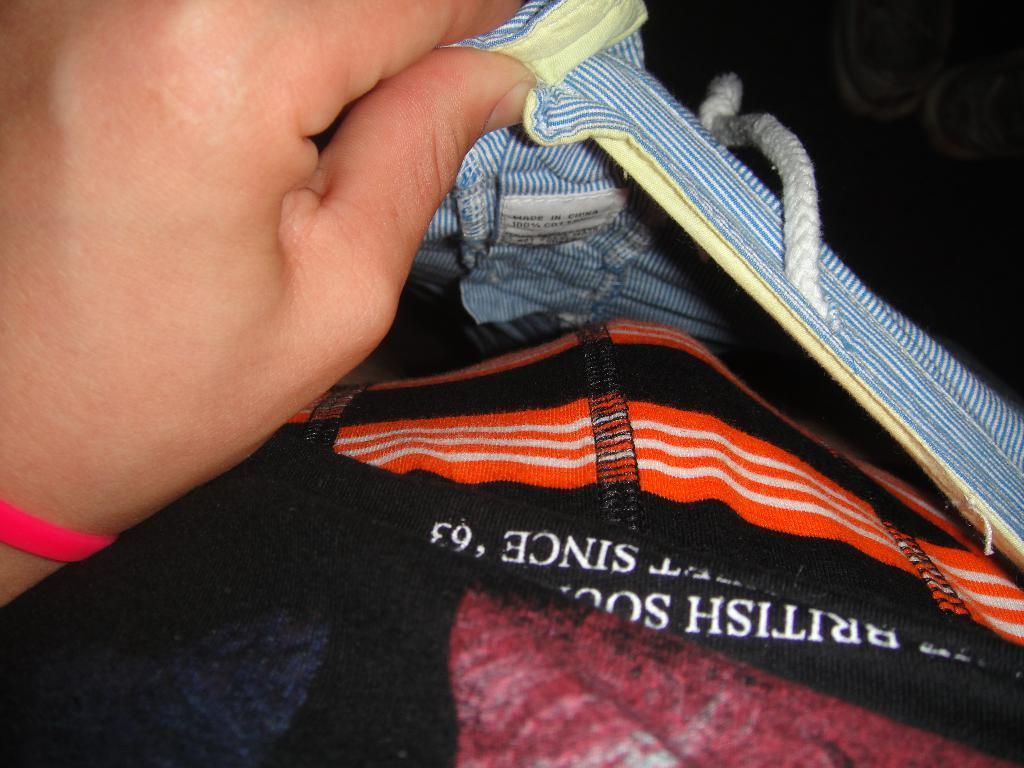Who or what is present in the image? There is a person in the image. What is the person holding? The person is holding clothes. Can you describe any additional details about the clothes? There is text written on the cloth. What phase of the moon is visible in the image? There is no moon visible in the image; it features a person holding clothes with text written on them. 